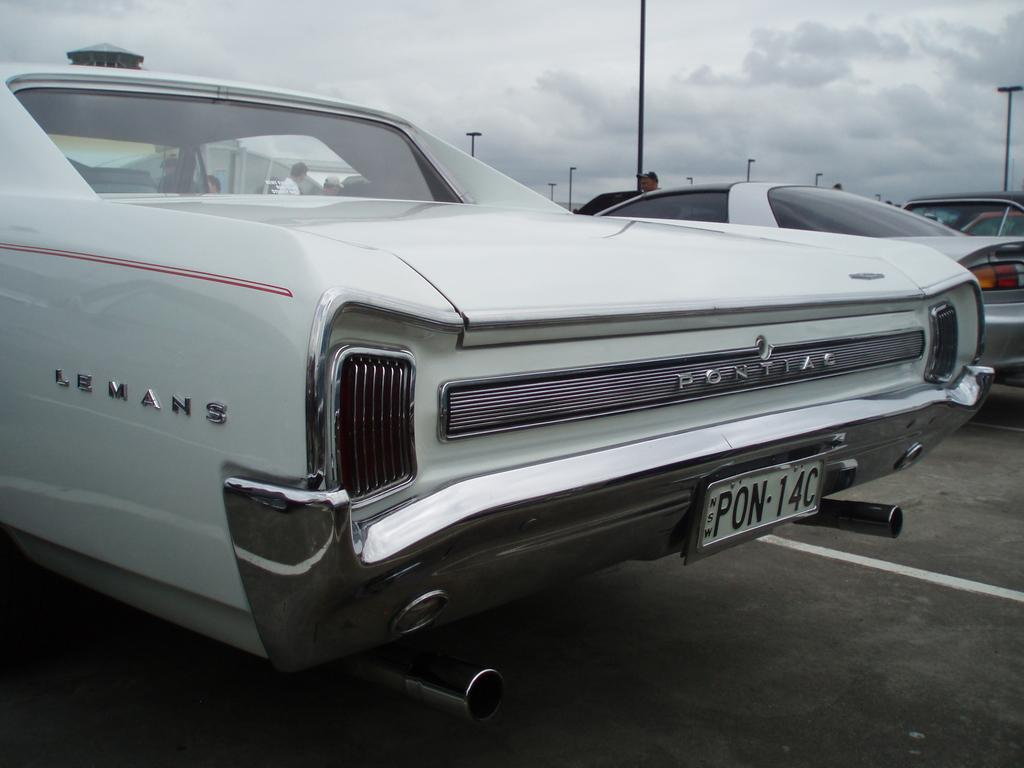Where was the image taken? The image was taken outside. What can be seen in the middle of the image? There are cars and poles in the middle of the image. What is visible at the top of the image? The sky is visible at the top of the image. What health advice is the person in the image giving to their son? There is no person or son present in the image, so no health advice can be observed. 